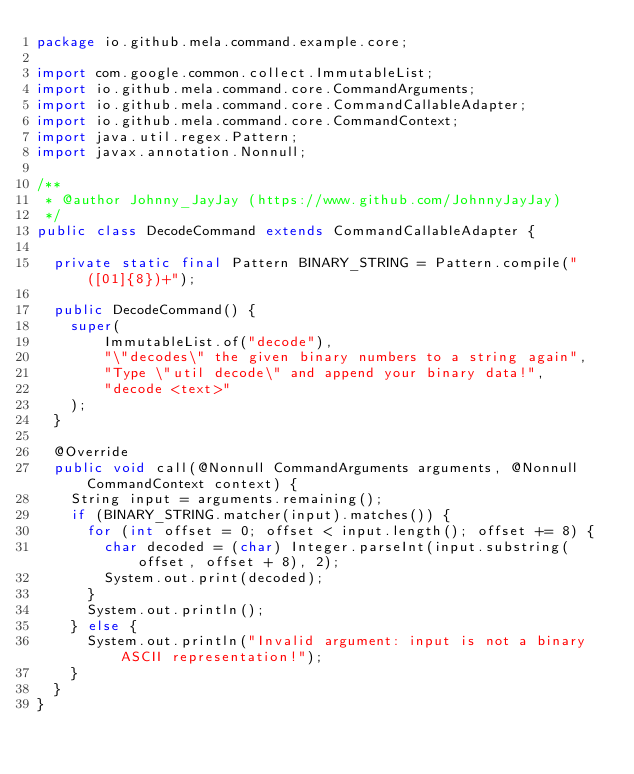Convert code to text. <code><loc_0><loc_0><loc_500><loc_500><_Java_>package io.github.mela.command.example.core;

import com.google.common.collect.ImmutableList;
import io.github.mela.command.core.CommandArguments;
import io.github.mela.command.core.CommandCallableAdapter;
import io.github.mela.command.core.CommandContext;
import java.util.regex.Pattern;
import javax.annotation.Nonnull;

/**
 * @author Johnny_JayJay (https://www.github.com/JohnnyJayJay)
 */
public class DecodeCommand extends CommandCallableAdapter {

  private static final Pattern BINARY_STRING = Pattern.compile("([01]{8})+");

  public DecodeCommand() {
    super(
        ImmutableList.of("decode"),
        "\"decodes\" the given binary numbers to a string again",
        "Type \"util decode\" and append your binary data!",
        "decode <text>"
    );
  }

  @Override
  public void call(@Nonnull CommandArguments arguments, @Nonnull CommandContext context) {
    String input = arguments.remaining();
    if (BINARY_STRING.matcher(input).matches()) {
      for (int offset = 0; offset < input.length(); offset += 8) {
        char decoded = (char) Integer.parseInt(input.substring(offset, offset + 8), 2);
        System.out.print(decoded);
      }
      System.out.println();
    } else {
      System.out.println("Invalid argument: input is not a binary ASCII representation!");
    }
  }
}
</code> 